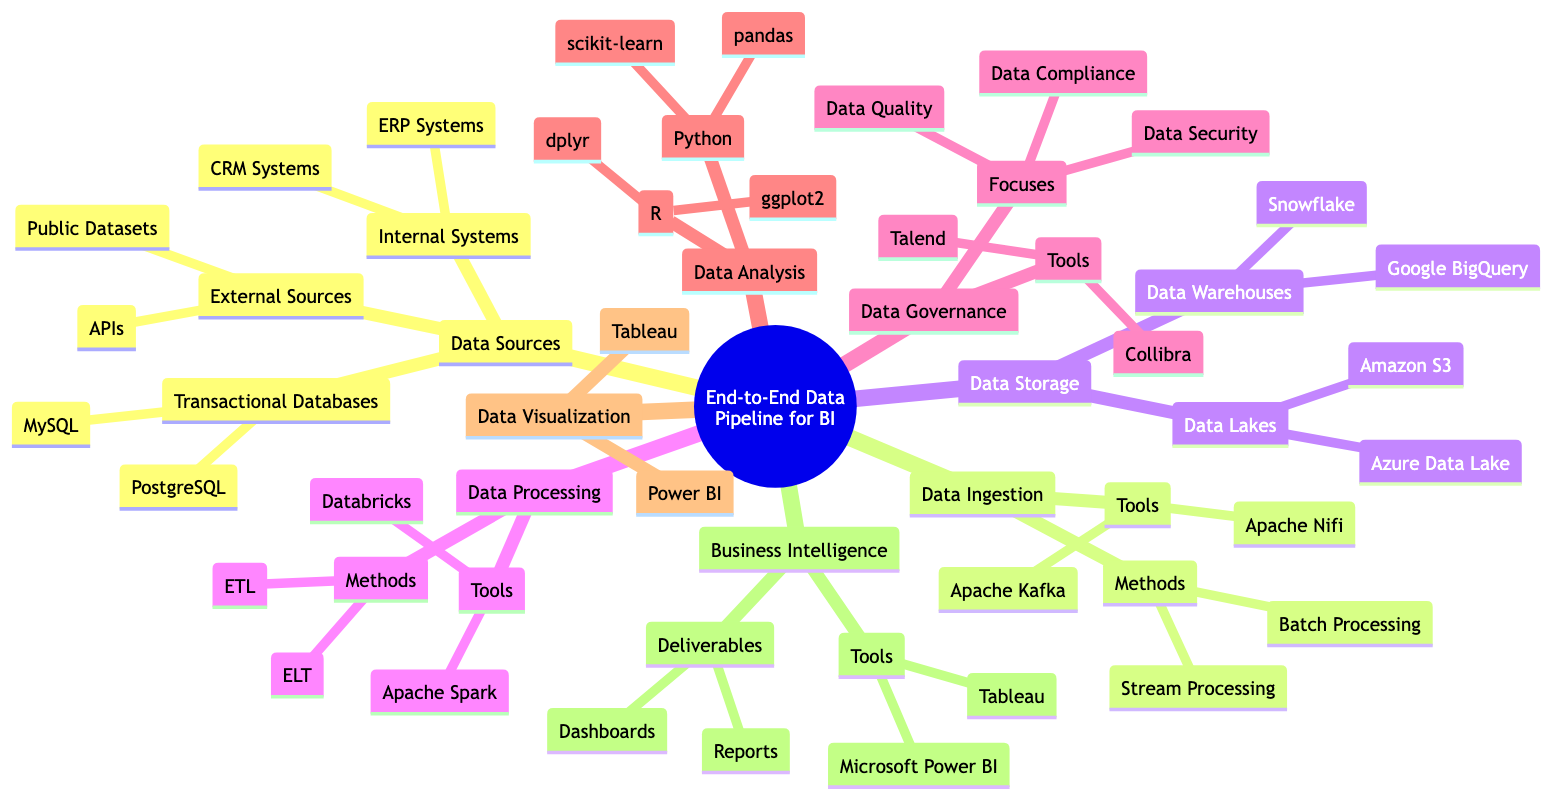What are three examples of Data Sources? The diagram lists three main categories under Data Sources: Transactional Databases, External Sources, and Internal Systems. Under each of these categories, specific examples are provided. For Transactional Databases, the examples are MySQL and PostgreSQL. For External Sources, they include APIs and Public Datasets. For Internal Systems, the examples are ERP Systems and CRM Systems. Therefore, we can summarize three examples as PostgreSQL, APIs, and ERP Systems.
Answer: PostgreSQL, APIs, ERP Systems What tools are used for Data Ingestion? Within the Data Ingestion node, the diagram specifies two methods: Batch Processing and Stream Processing. Under this node, it also lists two tools: Apache Kafka and Apache Nifi. Therefore, the tools used specifically for Data Ingestion are Apache Kafka and Apache Nifi.
Answer: Apache Kafka, Apache Nifi How many tools are listed under Data Storage? The Data Storage node contains two main options: Data Lakes and Data Warehouses. Under each of these, specific tools are mentioned. Under Data Lakes, there are two tools: Amazon S3 and Azure Data Lake. Under Data Warehouses, there are also two tools: Snowflake and Google BigQuery. Adding them together, we find a total of four tools.
Answer: 4 What are the focuses of Data Governance? The diagram shows that Data Governance has three main focuses listed directly under its node: Data Quality, Data Security, and Data Compliance. Thus, these three aspects represent what Data Governance prioritizes.
Answer: Data Quality, Data Security, Data Compliance Which method is used in Data Processing that includes transformation before loading? In the Data Processing section, the diagram outlines two methods, ETL and ELT. The ETL method stands for Extract, Transform, Load, indicating that it includes transformation before loading the data into storage. The ELT method, conversely, stands for Extract, Load, Transform, which means that transformation happens after loading. Hence, the method featuring transformation prior to loading is ETL.
Answer: ETL What are the deliverables listed under Business Intelligence? Looking at the Business Intelligence node, the diagram specifies two deliverables: Dashboards and Reports. These deliverables clarify what outputs result from the Business Intelligence processes described in the concept map.
Answer: Dashboards, Reports Which tools are related to Data Visualization? In the Data Visualization segment, the diagram lists two specific tools: Tableau and Power BI, indicating these tools are utilized for visualizing data in the context of Business Intelligence.
Answer: Tableau, Power BI What is the relationship between Data Analysis and Data Processing nodes? The diagram illustrates that Data Analysis directly follows Data Processing as part of the data pipeline. This indicates a relationship where Data Processing prepares the data and Data Analysis subsequently utilizes that data for insights. So the relationship highlights a sequential dependency where Analysis is contingent on the output of Processing.
Answer: Sequential dependency 